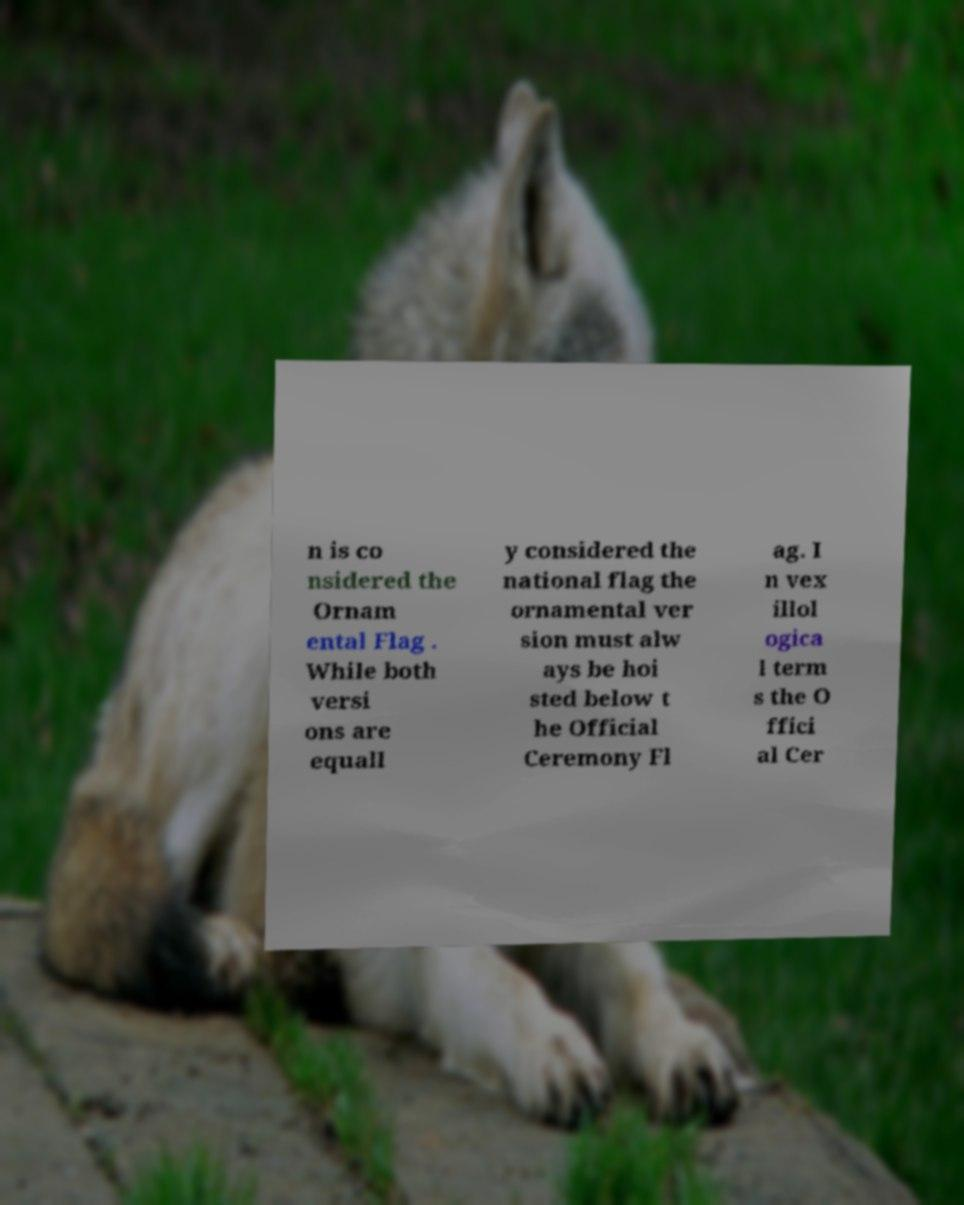Can you read and provide the text displayed in the image?This photo seems to have some interesting text. Can you extract and type it out for me? n is co nsidered the Ornam ental Flag . While both versi ons are equall y considered the national flag the ornamental ver sion must alw ays be hoi sted below t he Official Ceremony Fl ag. I n vex illol ogica l term s the O ffici al Cer 